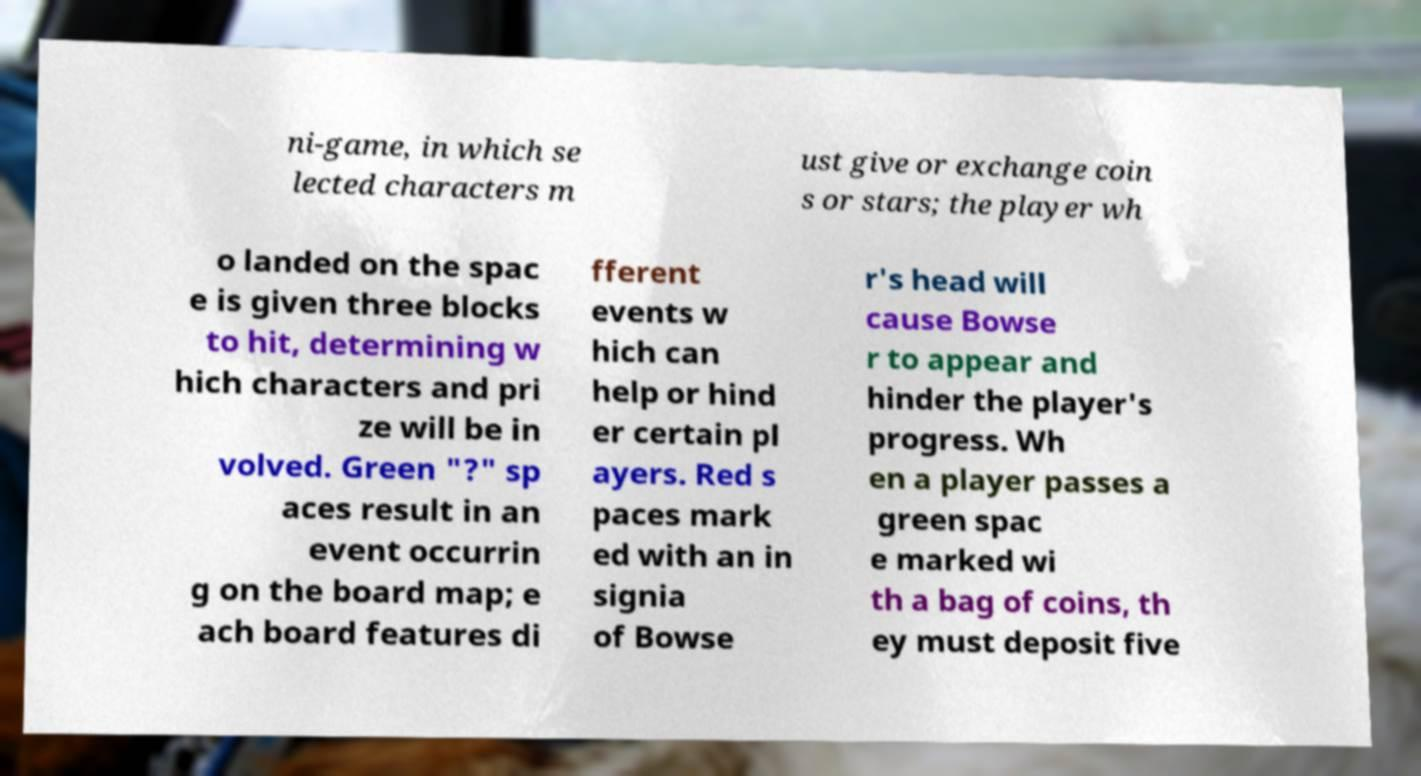Please read and relay the text visible in this image. What does it say? ni-game, in which se lected characters m ust give or exchange coin s or stars; the player wh o landed on the spac e is given three blocks to hit, determining w hich characters and pri ze will be in volved. Green "?" sp aces result in an event occurrin g on the board map; e ach board features di fferent events w hich can help or hind er certain pl ayers. Red s paces mark ed with an in signia of Bowse r's head will cause Bowse r to appear and hinder the player's progress. Wh en a player passes a green spac e marked wi th a bag of coins, th ey must deposit five 